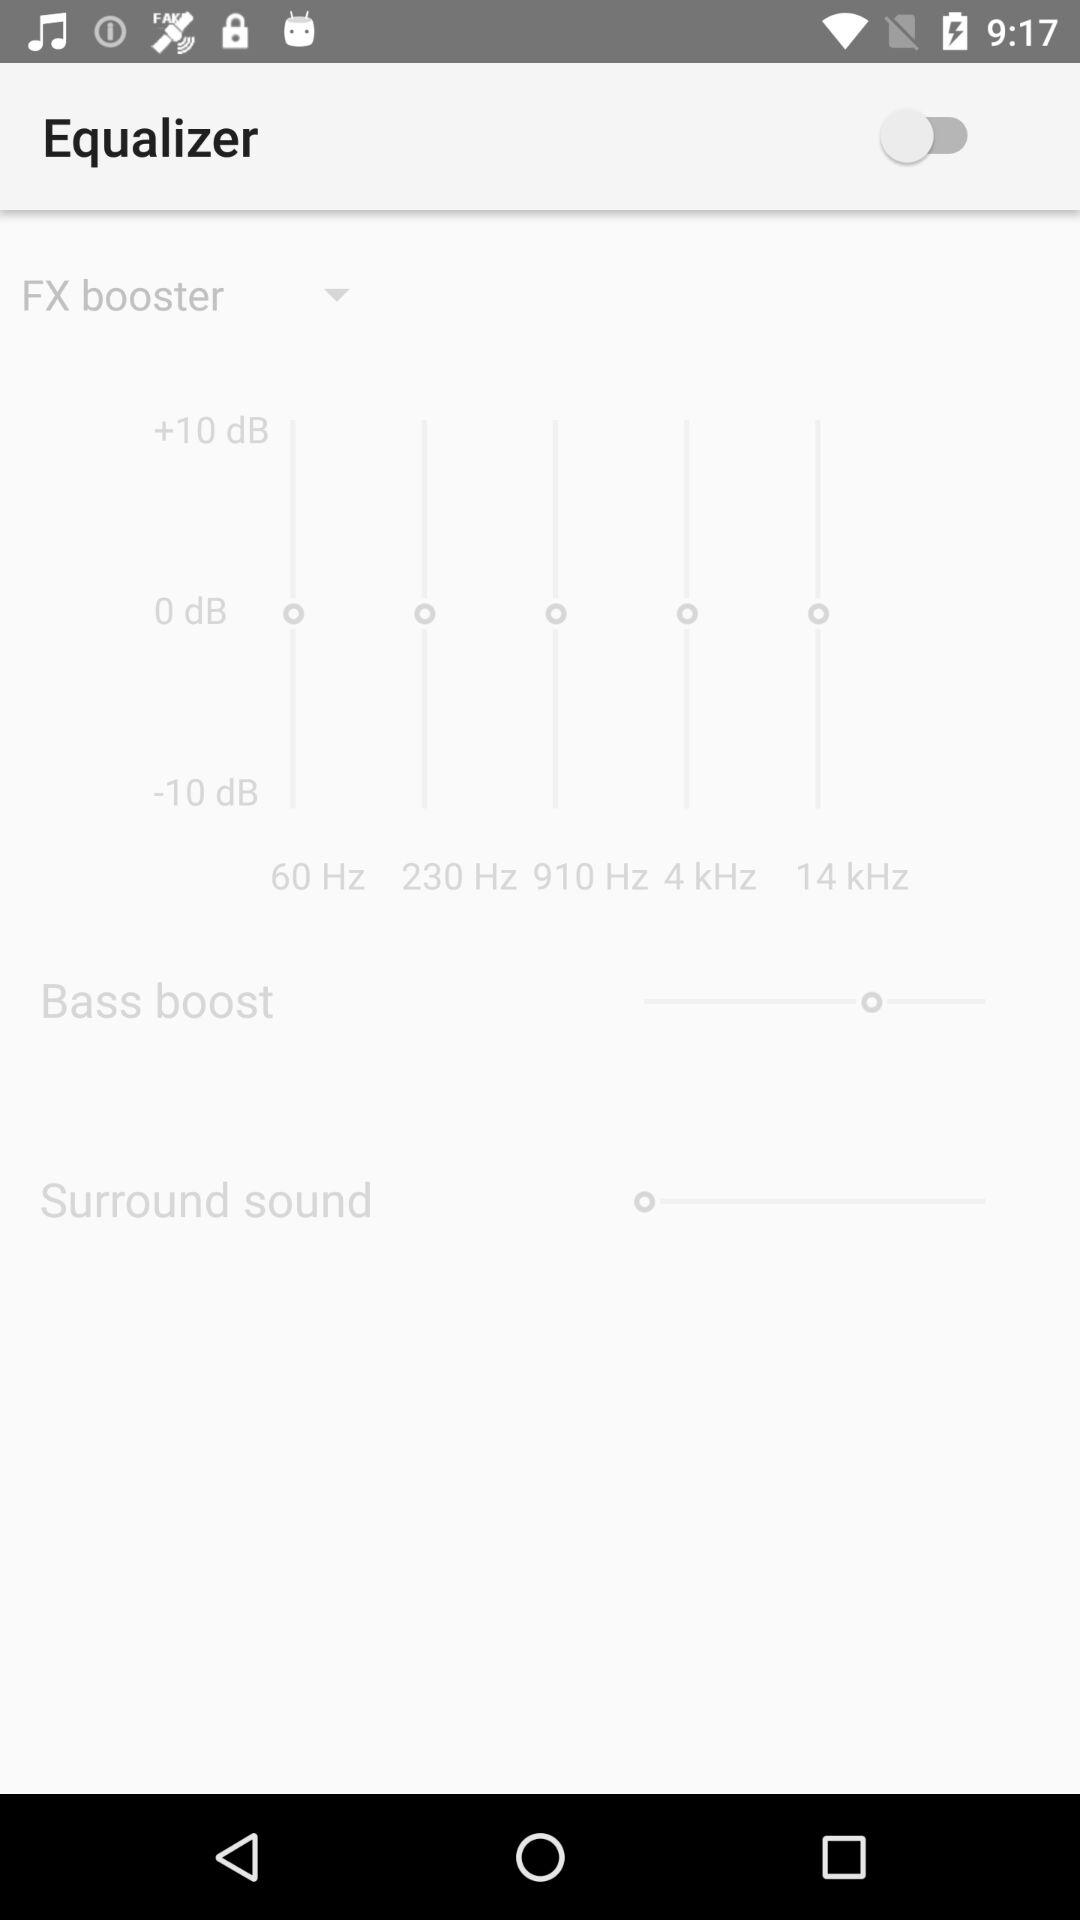How many dB options are there?
Answer the question using a single word or phrase. 3 